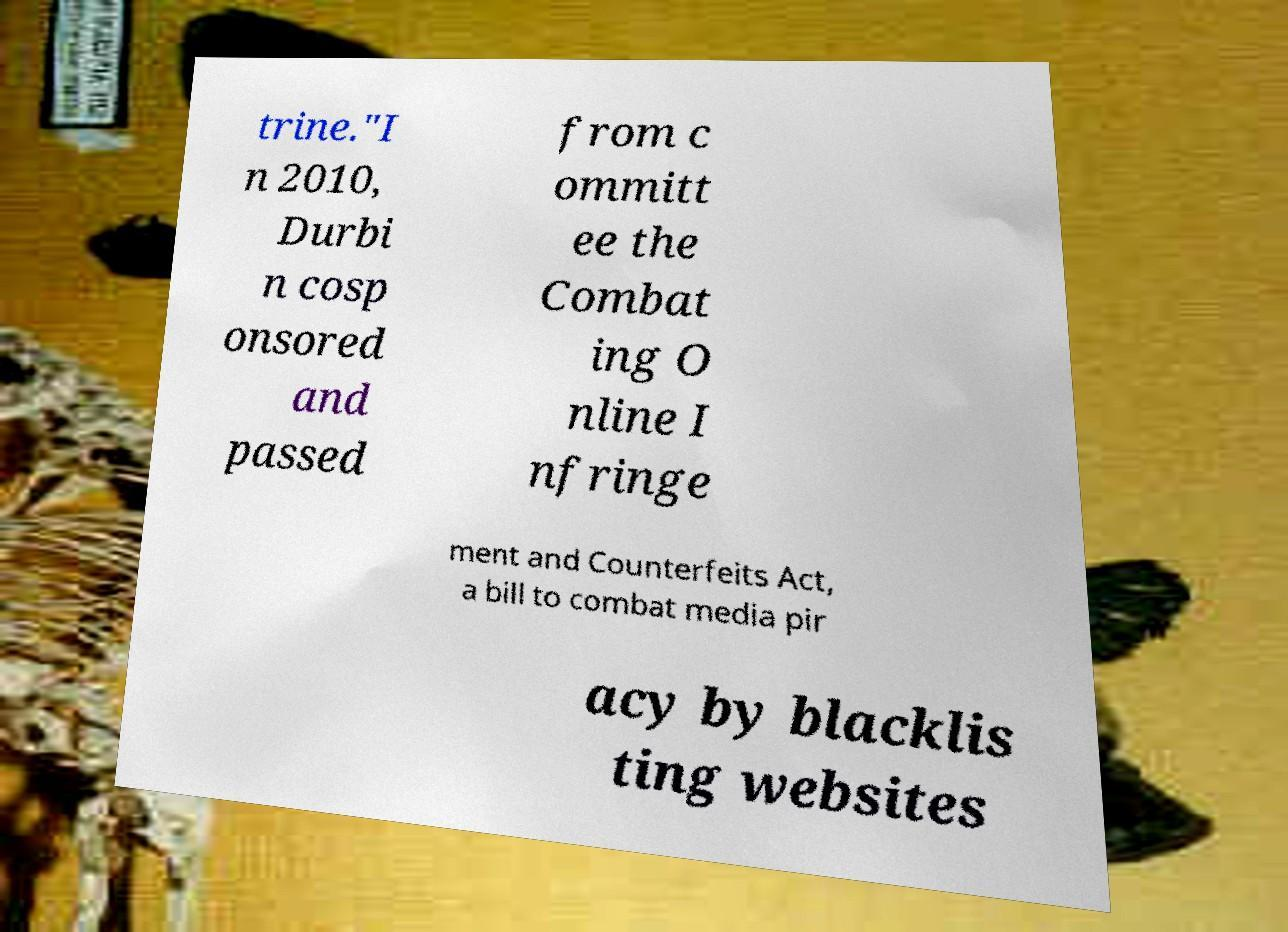For documentation purposes, I need the text within this image transcribed. Could you provide that? trine."I n 2010, Durbi n cosp onsored and passed from c ommitt ee the Combat ing O nline I nfringe ment and Counterfeits Act, a bill to combat media pir acy by blacklis ting websites 